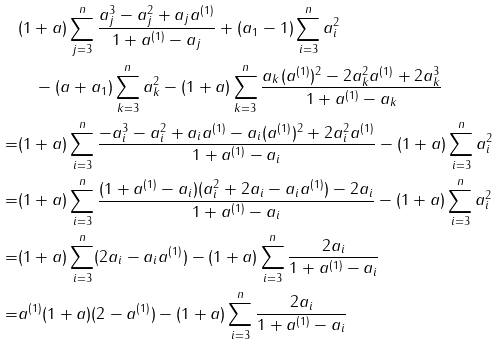Convert formula to latex. <formula><loc_0><loc_0><loc_500><loc_500>& ( 1 + a ) \sum _ { j = 3 } ^ { n } \frac { a _ { j } ^ { 3 } - a _ { j } ^ { 2 } + a _ { j } a ^ { ( 1 ) } } { 1 + a ^ { ( 1 ) } - a _ { j } } + ( a _ { 1 } - 1 ) \sum _ { i = 3 } ^ { n } a _ { i } ^ { 2 } \\ & \quad - ( a + a _ { 1 } ) \sum _ { k = 3 } ^ { n } a _ { k } ^ { 2 } - ( 1 + a ) \sum _ { k = 3 } ^ { n } \frac { a _ { k } ( a ^ { ( 1 ) } ) ^ { 2 } - 2 a _ { k } ^ { 2 } a ^ { ( 1 ) } + 2 a _ { k } ^ { 3 } } { 1 + a ^ { ( 1 ) } - a _ { k } } \\ = & ( 1 + a ) \sum _ { i = 3 } ^ { n } \frac { - a _ { i } ^ { 3 } - a _ { i } ^ { 2 } + a _ { i } a ^ { ( 1 ) } - a _ { i } ( a ^ { ( 1 ) } ) ^ { 2 } + 2 a _ { i } ^ { 2 } a ^ { ( 1 ) } } { 1 + a ^ { ( 1 ) } - a _ { i } } - ( 1 + a ) \sum _ { i = 3 } ^ { n } a _ { i } ^ { 2 } \\ = & ( 1 + a ) \sum _ { i = 3 } ^ { n } \frac { ( 1 + a ^ { ( 1 ) } - a _ { i } ) ( a _ { i } ^ { 2 } + 2 a _ { i } - a _ { i } a ^ { ( 1 ) } ) - 2 a _ { i } } { 1 + a ^ { ( 1 ) } - a _ { i } } - ( 1 + a ) \sum _ { i = 3 } ^ { n } a _ { i } ^ { 2 } \\ = & ( 1 + a ) \sum _ { i = 3 } ^ { n } ( 2 a _ { i } - a _ { i } a ^ { ( 1 ) } ) - ( 1 + a ) \sum _ { i = 3 } ^ { n } \frac { 2 a _ { i } } { 1 + a ^ { ( 1 ) } - a _ { i } } \\ = & a ^ { ( 1 ) } ( 1 + a ) ( 2 - a ^ { ( 1 ) } ) - ( 1 + a ) \sum _ { i = 3 } ^ { n } \frac { 2 a _ { i } } { 1 + a ^ { ( 1 ) } - a _ { i } }</formula> 